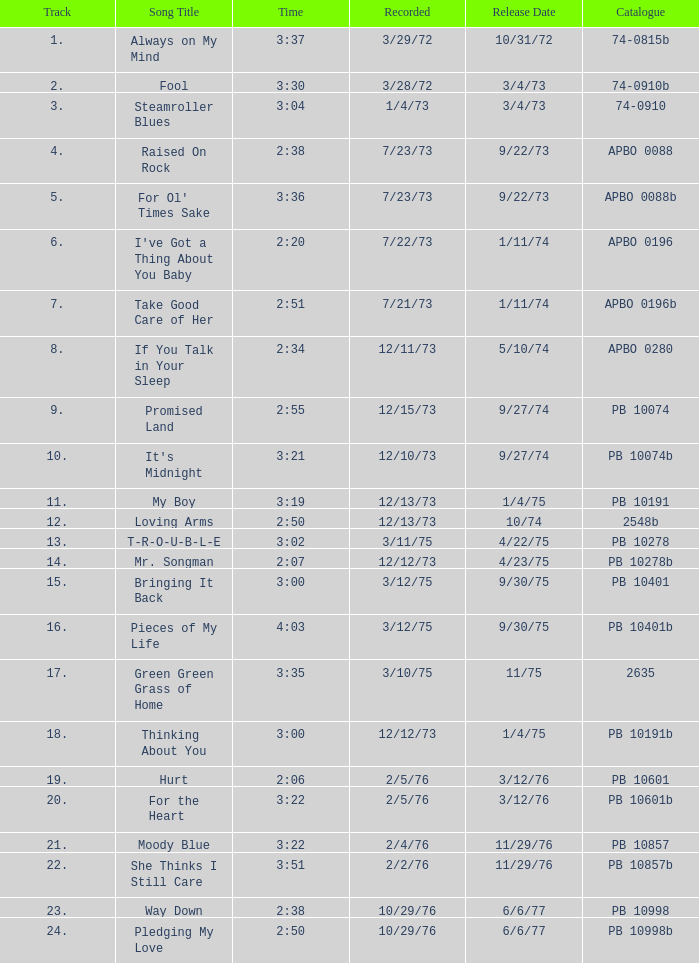Tell me the release date record on 10/29/76 and a time on 2:50 6/6/77. 